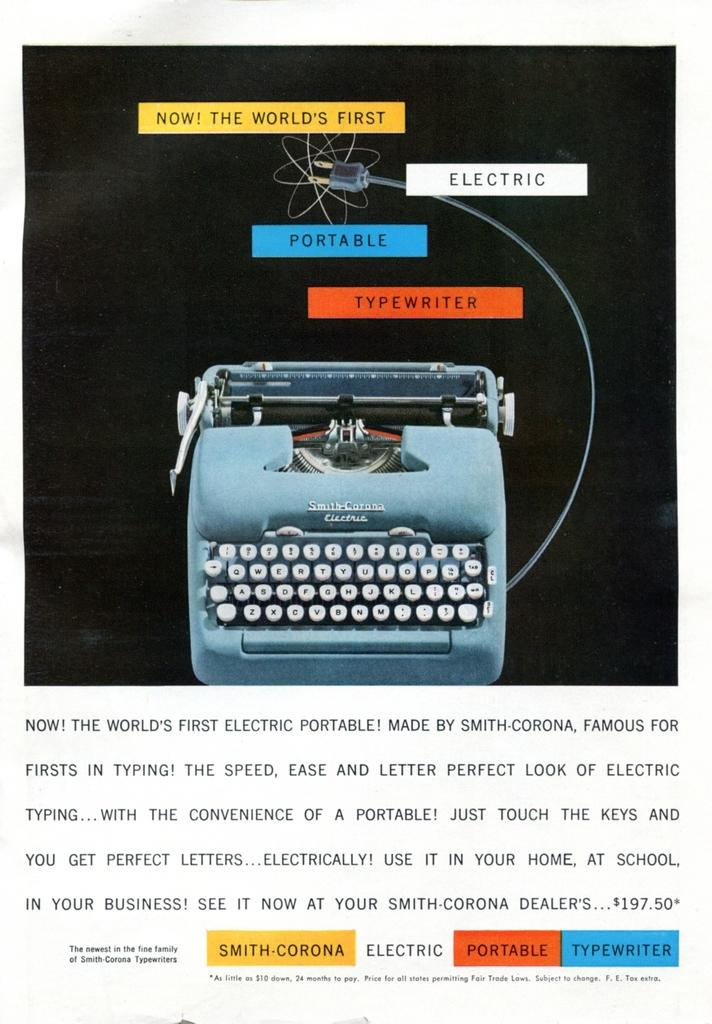Provide a one-sentence caption for the provided image. the world's first portable electric typewriter with a paragraph describing it. 